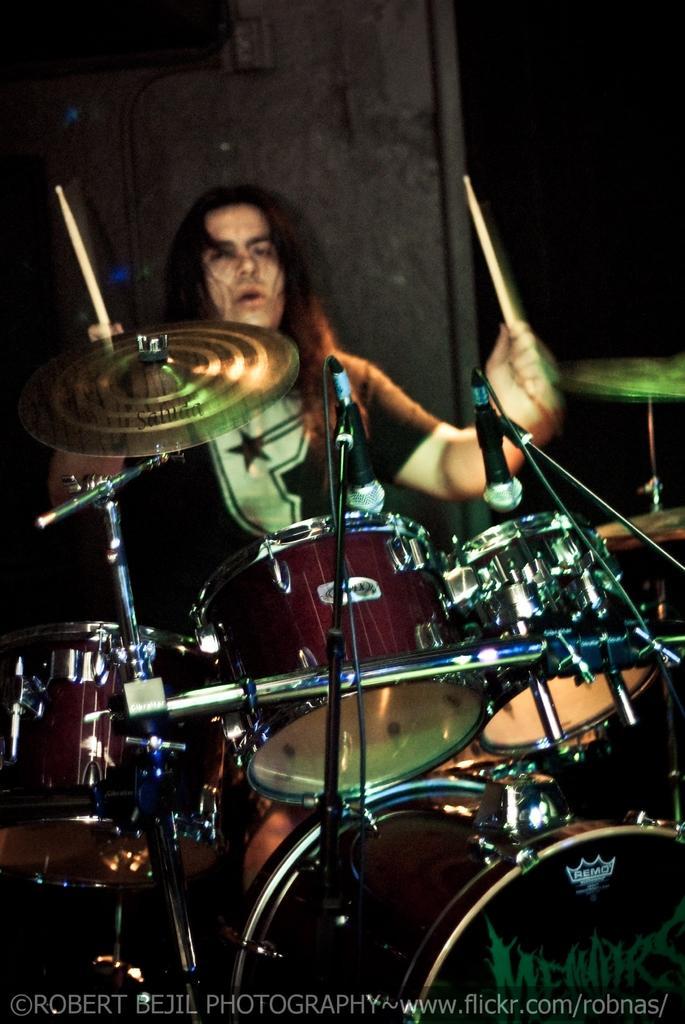Please provide a concise description of this image. In this image we can see a person playing drums. A person is holding sticks in his hands. 